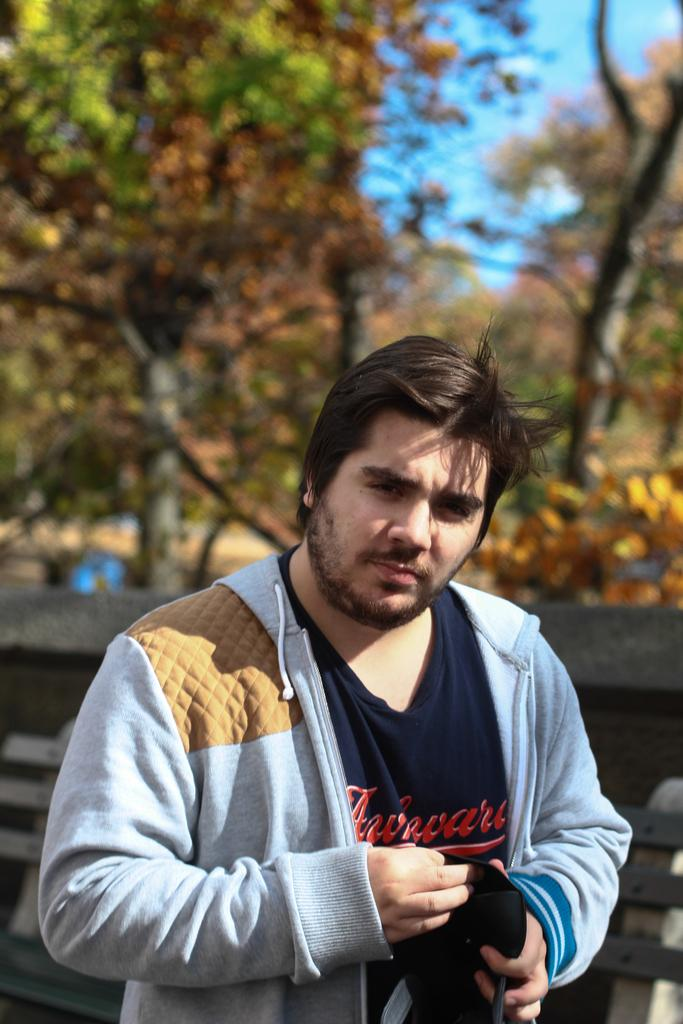Who is present in the image? There is a man in the image. What can be seen in the background of the image? Trees and the sky are visible in the background of the image. What type of drug is the man offering in the image? There is no indication in the image that the man is offering any drug, and therefore no such activity can be observed. 